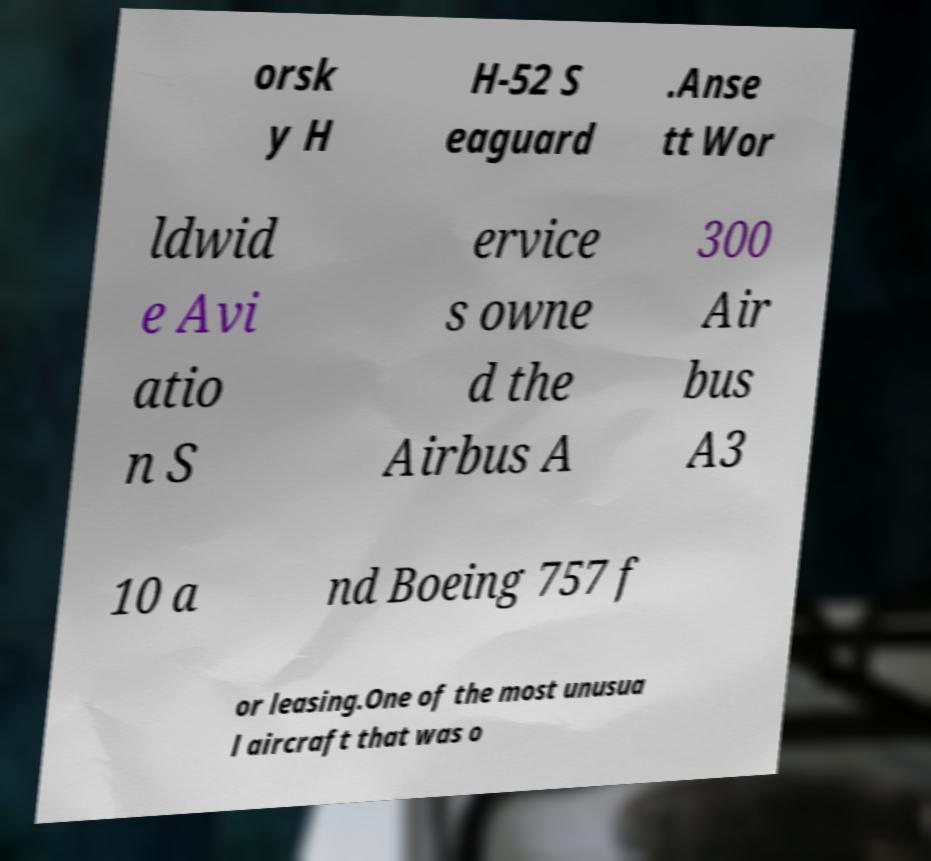I need the written content from this picture converted into text. Can you do that? orsk y H H-52 S eaguard .Anse tt Wor ldwid e Avi atio n S ervice s owne d the Airbus A 300 Air bus A3 10 a nd Boeing 757 f or leasing.One of the most unusua l aircraft that was o 